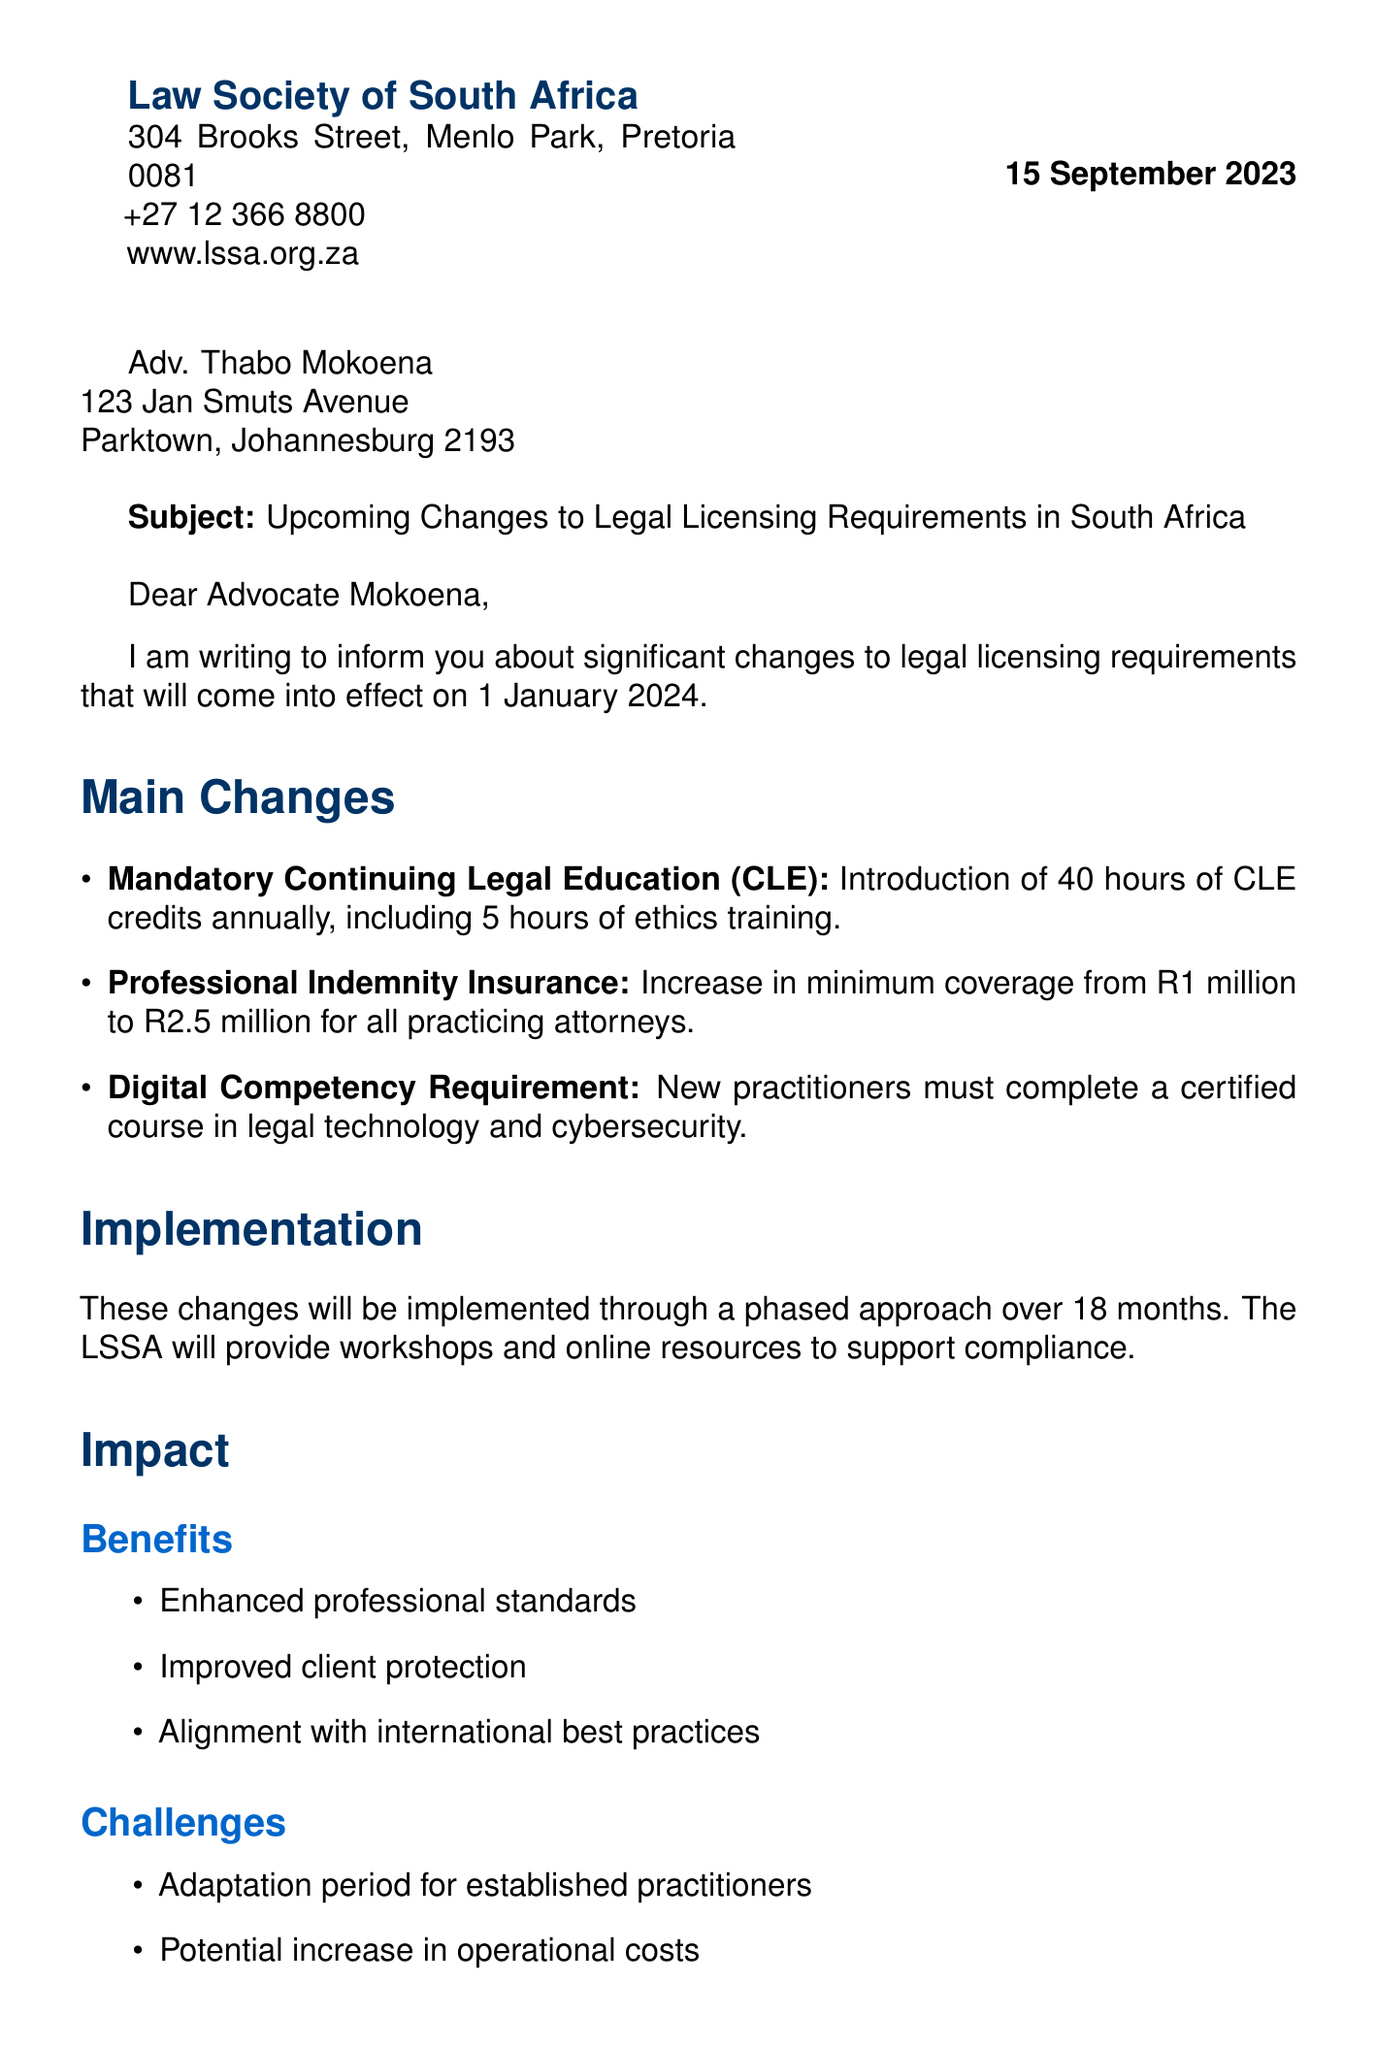what is the subject of the letter? The subject of the letter is specified in the subject line which discusses the upcoming changes to legal licensing requirements.
Answer: Upcoming Changes to Legal Licensing Requirements in South Africa when is the effective date of the changes? The effective date is mentioned in the introduction section of the letter.
Answer: 1 January 2024 how many hours of CLE credits are required annually? The main changes section states the number of CLE credits required annually.
Answer: 40 hours what is the new minimum coverage for professional indemnity insurance? This information can be found in the details of the professional indemnity insurance section.
Answer: R2.5 million what is the compliance deadline for the new requirements? The compliance deadline is stated in the compliance section of the letter.
Answer: 31 December 2024 who is the signatory of the letter? The signature section mentions the author of the letter.
Answer: Ms. Nomonde Gxilishe what support is being provided for compliance? The implementation section includes details about the support provided by the LSSA for compliance.
Answer: Workshops and online resources what is one benefit of the upcoming changes? The benefits section lists several benefits, one of which can be highlighted.
Answer: Enhanced professional standards what challenges might practitioners face due to the changes? This information is drawn from the challenges listed in the impact section of the letter.
Answer: Adaptation period for established practitioners 